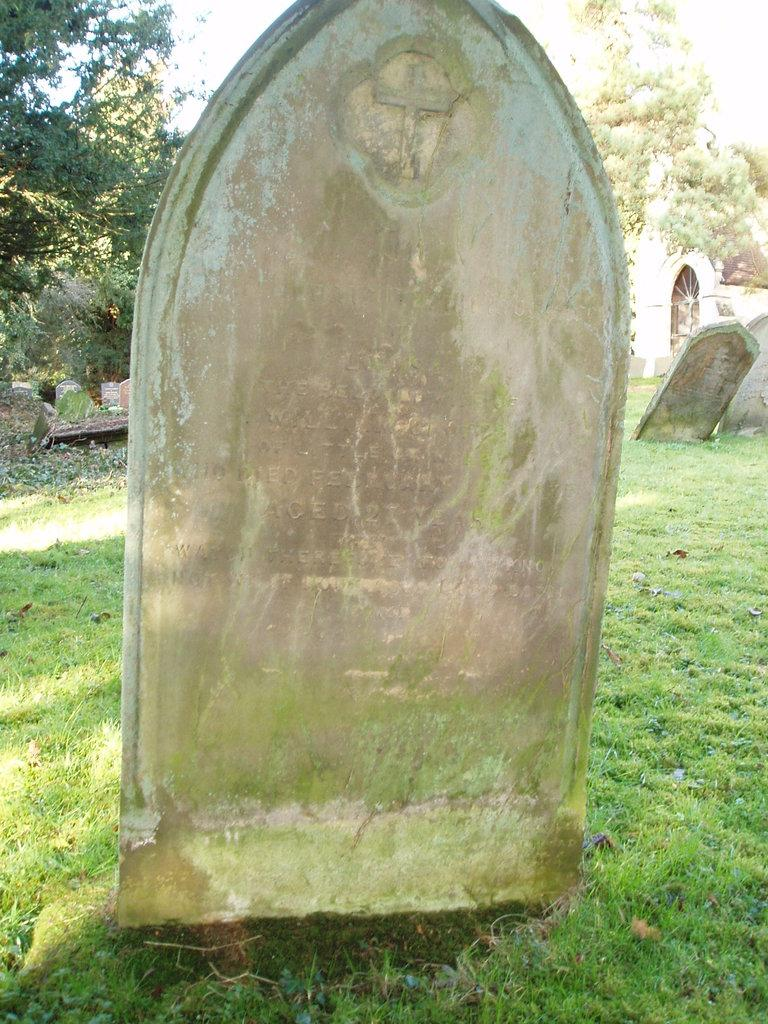What is the main object in the image? There is a gravestone in the image. How is the gravestone positioned in the image? The gravestone is on the ground. What type of vegetation is present in the image? There is grass on the ground in the image. What can be seen in the background of the image? There are trees in the background of the image. Where is the coach parked in the image? There is no coach present in the image; it only features a gravestone, grass, and trees. What type of coat is hanging on the hook in the image? There is no coat or hook present in the image. 